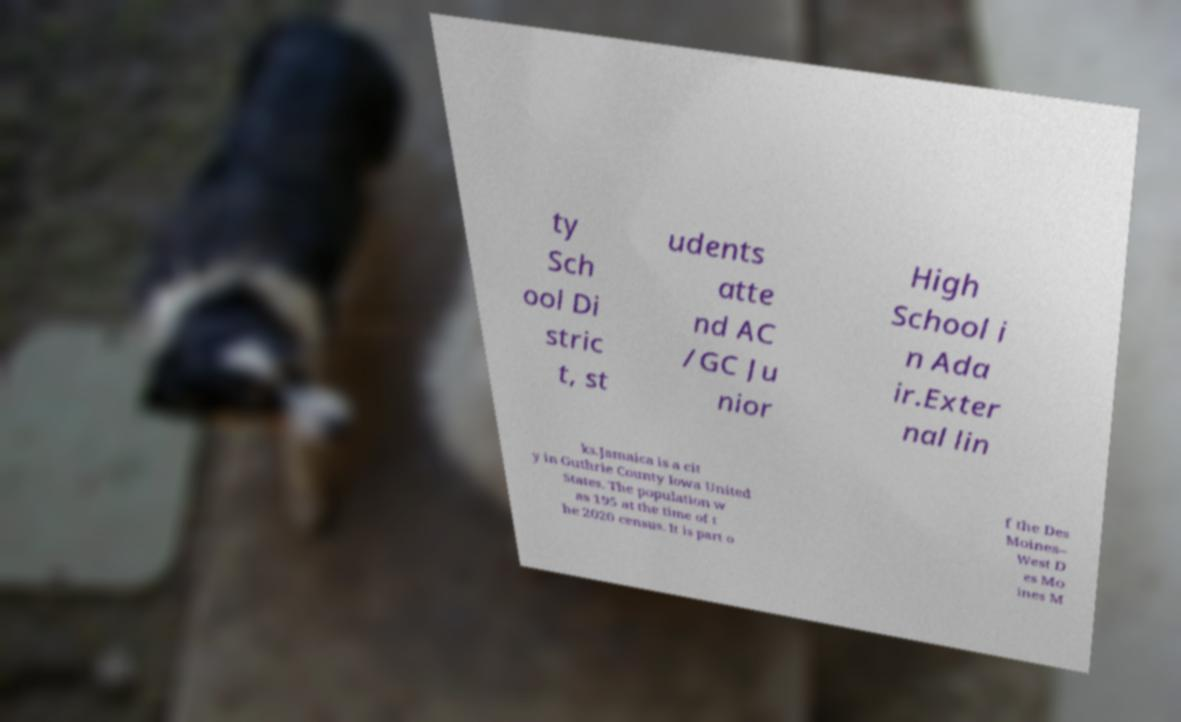Can you read and provide the text displayed in the image?This photo seems to have some interesting text. Can you extract and type it out for me? ty Sch ool Di stric t, st udents atte nd AC /GC Ju nior High School i n Ada ir.Exter nal lin ks.Jamaica is a cit y in Guthrie County Iowa United States. The population w as 195 at the time of t he 2020 census. It is part o f the Des Moines– West D es Mo ines M 